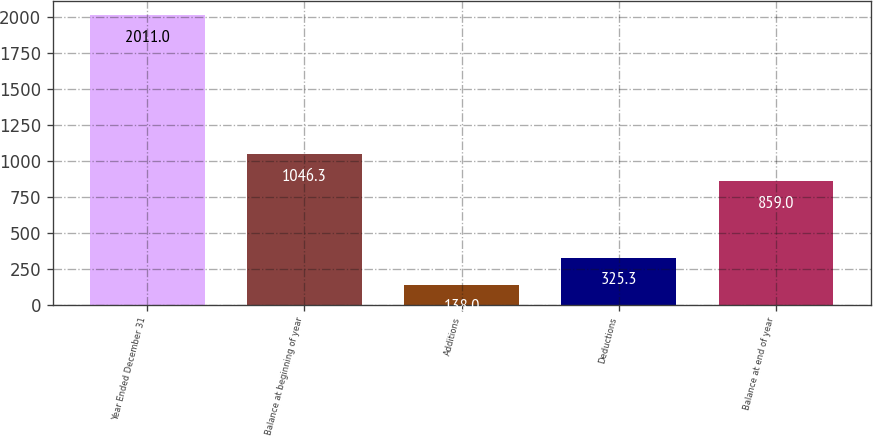Convert chart to OTSL. <chart><loc_0><loc_0><loc_500><loc_500><bar_chart><fcel>Year Ended December 31<fcel>Balance at beginning of year<fcel>Additions<fcel>Deductions<fcel>Balance at end of year<nl><fcel>2011<fcel>1046.3<fcel>138<fcel>325.3<fcel>859<nl></chart> 